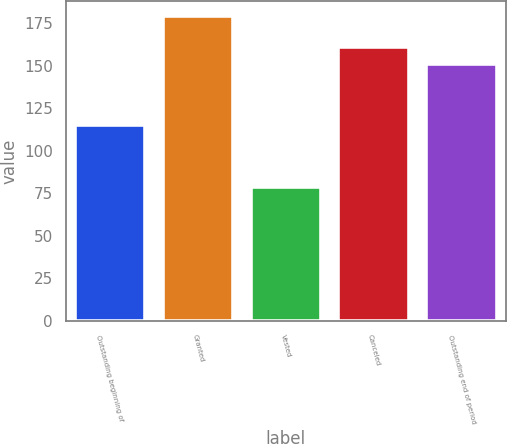Convert chart to OTSL. <chart><loc_0><loc_0><loc_500><loc_500><bar_chart><fcel>Outstanding beginning of<fcel>Granted<fcel>Vested<fcel>Canceled<fcel>Outstanding end of period<nl><fcel>115.01<fcel>179.17<fcel>78.65<fcel>161.01<fcel>150.96<nl></chart> 